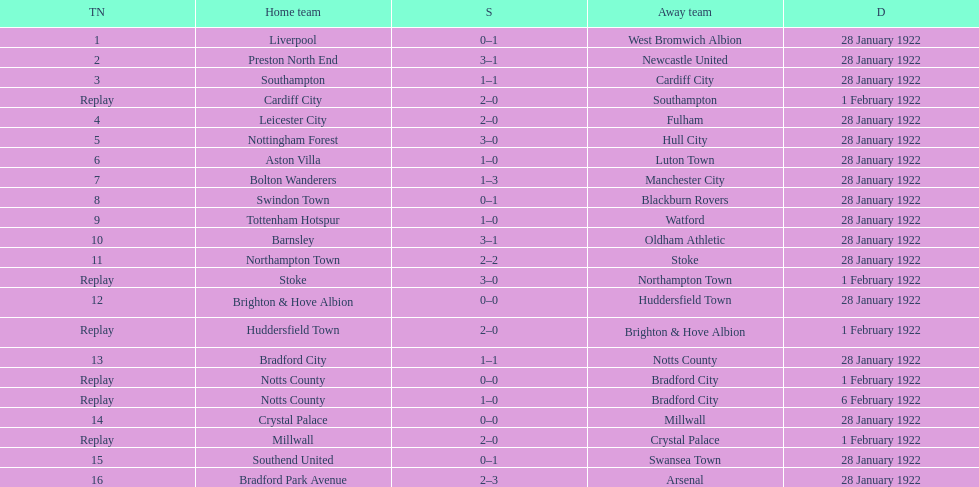What date did they play before feb 1? 28 January 1922. 